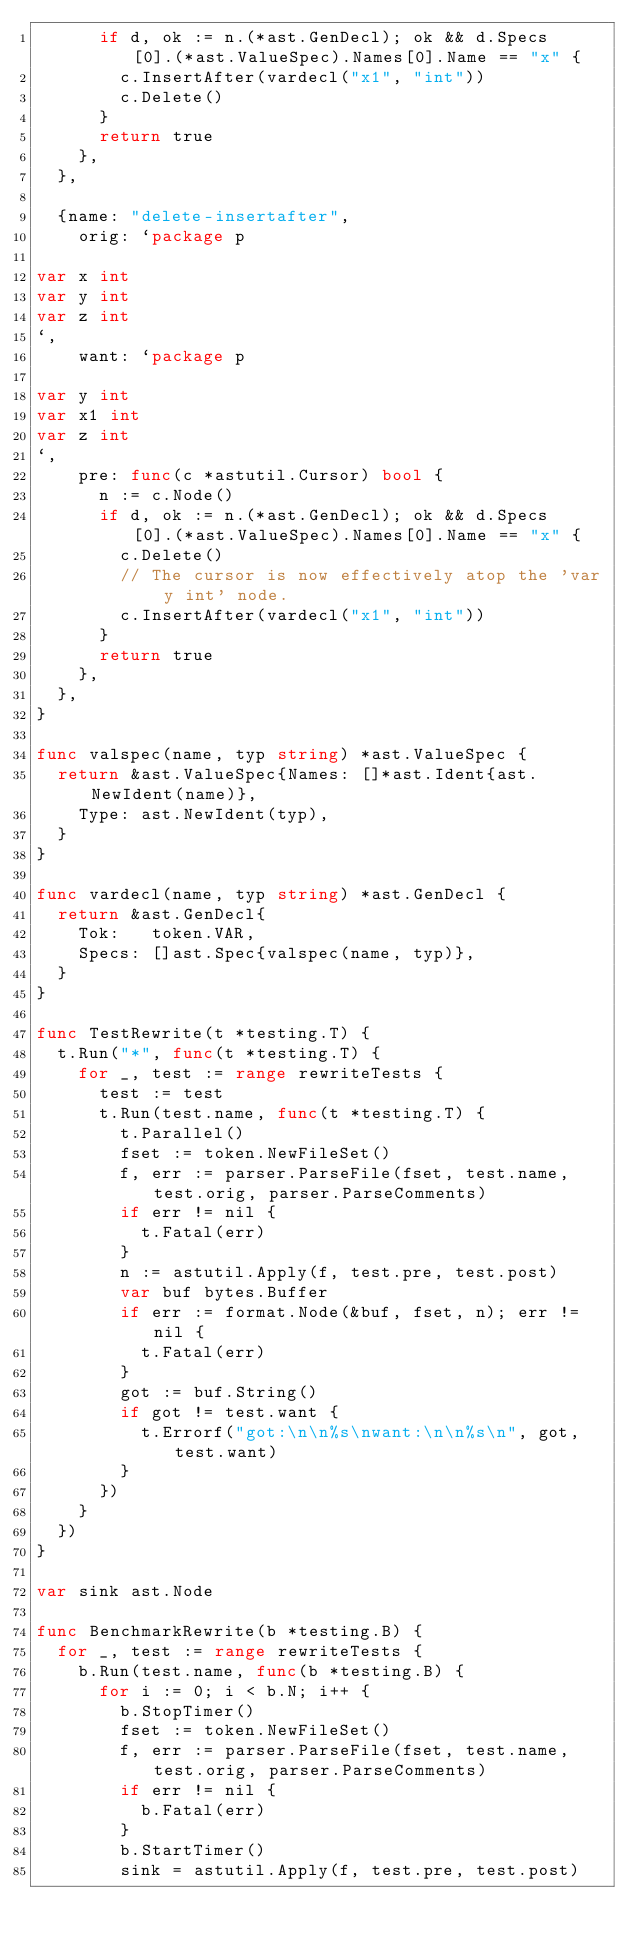<code> <loc_0><loc_0><loc_500><loc_500><_Go_>			if d, ok := n.(*ast.GenDecl); ok && d.Specs[0].(*ast.ValueSpec).Names[0].Name == "x" {
				c.InsertAfter(vardecl("x1", "int"))
				c.Delete()
			}
			return true
		},
	},

	{name: "delete-insertafter",
		orig: `package p

var x int
var y int
var z int
`,
		want: `package p

var y int
var x1 int
var z int
`,
		pre: func(c *astutil.Cursor) bool {
			n := c.Node()
			if d, ok := n.(*ast.GenDecl); ok && d.Specs[0].(*ast.ValueSpec).Names[0].Name == "x" {
				c.Delete()
				// The cursor is now effectively atop the 'var y int' node.
				c.InsertAfter(vardecl("x1", "int"))
			}
			return true
		},
	},
}

func valspec(name, typ string) *ast.ValueSpec {
	return &ast.ValueSpec{Names: []*ast.Ident{ast.NewIdent(name)},
		Type: ast.NewIdent(typ),
	}
}

func vardecl(name, typ string) *ast.GenDecl {
	return &ast.GenDecl{
		Tok:   token.VAR,
		Specs: []ast.Spec{valspec(name, typ)},
	}
}

func TestRewrite(t *testing.T) {
	t.Run("*", func(t *testing.T) {
		for _, test := range rewriteTests {
			test := test
			t.Run(test.name, func(t *testing.T) {
				t.Parallel()
				fset := token.NewFileSet()
				f, err := parser.ParseFile(fset, test.name, test.orig, parser.ParseComments)
				if err != nil {
					t.Fatal(err)
				}
				n := astutil.Apply(f, test.pre, test.post)
				var buf bytes.Buffer
				if err := format.Node(&buf, fset, n); err != nil {
					t.Fatal(err)
				}
				got := buf.String()
				if got != test.want {
					t.Errorf("got:\n\n%s\nwant:\n\n%s\n", got, test.want)
				}
			})
		}
	})
}

var sink ast.Node

func BenchmarkRewrite(b *testing.B) {
	for _, test := range rewriteTests {
		b.Run(test.name, func(b *testing.B) {
			for i := 0; i < b.N; i++ {
				b.StopTimer()
				fset := token.NewFileSet()
				f, err := parser.ParseFile(fset, test.name, test.orig, parser.ParseComments)
				if err != nil {
					b.Fatal(err)
				}
				b.StartTimer()
				sink = astutil.Apply(f, test.pre, test.post)</code> 